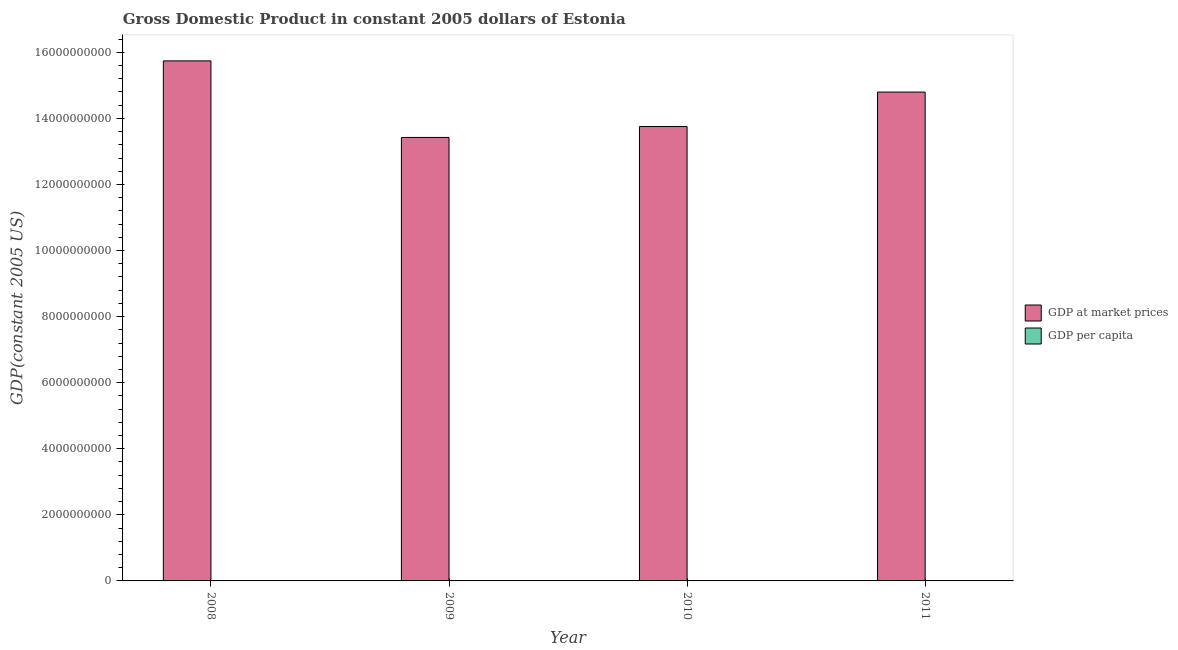How many groups of bars are there?
Provide a short and direct response. 4. What is the label of the 1st group of bars from the left?
Give a very brief answer. 2008. In how many cases, is the number of bars for a given year not equal to the number of legend labels?
Offer a very short reply. 0. What is the gdp at market prices in 2009?
Offer a very short reply. 1.34e+1. Across all years, what is the maximum gdp per capita?
Provide a short and direct response. 1.18e+04. Across all years, what is the minimum gdp at market prices?
Offer a very short reply. 1.34e+1. In which year was the gdp per capita maximum?
Make the answer very short. 2008. What is the total gdp at market prices in the graph?
Ensure brevity in your answer.  5.77e+1. What is the difference between the gdp per capita in 2008 and that in 2009?
Your answer should be compact. 1713.92. What is the difference between the gdp per capita in 2011 and the gdp at market prices in 2009?
Your response must be concise. 1088.26. What is the average gdp at market prices per year?
Ensure brevity in your answer.  1.44e+1. In the year 2010, what is the difference between the gdp at market prices and gdp per capita?
Keep it short and to the point. 0. In how many years, is the gdp per capita greater than 800000000 US$?
Offer a terse response. 0. What is the ratio of the gdp per capita in 2008 to that in 2011?
Offer a terse response. 1.06. Is the gdp at market prices in 2008 less than that in 2009?
Provide a succinct answer. No. What is the difference between the highest and the second highest gdp per capita?
Give a very brief answer. 625.66. What is the difference between the highest and the lowest gdp per capita?
Make the answer very short. 1713.92. In how many years, is the gdp at market prices greater than the average gdp at market prices taken over all years?
Your answer should be very brief. 2. What does the 2nd bar from the left in 2011 represents?
Make the answer very short. GDP per capita. What does the 1st bar from the right in 2008 represents?
Make the answer very short. GDP per capita. Are all the bars in the graph horizontal?
Your response must be concise. No. What is the difference between two consecutive major ticks on the Y-axis?
Offer a very short reply. 2.00e+09. Are the values on the major ticks of Y-axis written in scientific E-notation?
Ensure brevity in your answer.  No. Does the graph contain any zero values?
Provide a short and direct response. No. How many legend labels are there?
Provide a short and direct response. 2. What is the title of the graph?
Offer a terse response. Gross Domestic Product in constant 2005 dollars of Estonia. Does "Secondary education" appear as one of the legend labels in the graph?
Your response must be concise. No. What is the label or title of the Y-axis?
Ensure brevity in your answer.  GDP(constant 2005 US). What is the GDP(constant 2005 US) in GDP at market prices in 2008?
Make the answer very short. 1.57e+1. What is the GDP(constant 2005 US) of GDP per capita in 2008?
Your response must be concise. 1.18e+04. What is the GDP(constant 2005 US) in GDP at market prices in 2009?
Give a very brief answer. 1.34e+1. What is the GDP(constant 2005 US) of GDP per capita in 2009?
Your answer should be very brief. 1.01e+04. What is the GDP(constant 2005 US) of GDP at market prices in 2010?
Give a very brief answer. 1.38e+1. What is the GDP(constant 2005 US) of GDP per capita in 2010?
Keep it short and to the point. 1.03e+04. What is the GDP(constant 2005 US) in GDP at market prices in 2011?
Your answer should be compact. 1.48e+1. What is the GDP(constant 2005 US) in GDP per capita in 2011?
Provide a succinct answer. 1.11e+04. Across all years, what is the maximum GDP(constant 2005 US) of GDP at market prices?
Offer a very short reply. 1.57e+1. Across all years, what is the maximum GDP(constant 2005 US) in GDP per capita?
Offer a terse response. 1.18e+04. Across all years, what is the minimum GDP(constant 2005 US) of GDP at market prices?
Give a very brief answer. 1.34e+1. Across all years, what is the minimum GDP(constant 2005 US) in GDP per capita?
Your answer should be compact. 1.01e+04. What is the total GDP(constant 2005 US) in GDP at market prices in the graph?
Your response must be concise. 5.77e+1. What is the total GDP(constant 2005 US) in GDP per capita in the graph?
Keep it short and to the point. 4.33e+04. What is the difference between the GDP(constant 2005 US) in GDP at market prices in 2008 and that in 2009?
Your answer should be compact. 2.32e+09. What is the difference between the GDP(constant 2005 US) of GDP per capita in 2008 and that in 2009?
Your answer should be very brief. 1713.92. What is the difference between the GDP(constant 2005 US) in GDP at market prices in 2008 and that in 2010?
Ensure brevity in your answer.  1.99e+09. What is the difference between the GDP(constant 2005 US) in GDP per capita in 2008 and that in 2010?
Provide a succinct answer. 1442.69. What is the difference between the GDP(constant 2005 US) of GDP at market prices in 2008 and that in 2011?
Make the answer very short. 9.44e+08. What is the difference between the GDP(constant 2005 US) of GDP per capita in 2008 and that in 2011?
Provide a short and direct response. 625.66. What is the difference between the GDP(constant 2005 US) in GDP at market prices in 2009 and that in 2010?
Your response must be concise. -3.31e+08. What is the difference between the GDP(constant 2005 US) in GDP per capita in 2009 and that in 2010?
Make the answer very short. -271.23. What is the difference between the GDP(constant 2005 US) in GDP at market prices in 2009 and that in 2011?
Your answer should be compact. -1.37e+09. What is the difference between the GDP(constant 2005 US) of GDP per capita in 2009 and that in 2011?
Provide a short and direct response. -1088.26. What is the difference between the GDP(constant 2005 US) of GDP at market prices in 2010 and that in 2011?
Make the answer very short. -1.04e+09. What is the difference between the GDP(constant 2005 US) in GDP per capita in 2010 and that in 2011?
Give a very brief answer. -817.03. What is the difference between the GDP(constant 2005 US) in GDP at market prices in 2008 and the GDP(constant 2005 US) in GDP per capita in 2009?
Your answer should be compact. 1.57e+1. What is the difference between the GDP(constant 2005 US) in GDP at market prices in 2008 and the GDP(constant 2005 US) in GDP per capita in 2010?
Your answer should be compact. 1.57e+1. What is the difference between the GDP(constant 2005 US) of GDP at market prices in 2008 and the GDP(constant 2005 US) of GDP per capita in 2011?
Offer a very short reply. 1.57e+1. What is the difference between the GDP(constant 2005 US) of GDP at market prices in 2009 and the GDP(constant 2005 US) of GDP per capita in 2010?
Keep it short and to the point. 1.34e+1. What is the difference between the GDP(constant 2005 US) in GDP at market prices in 2009 and the GDP(constant 2005 US) in GDP per capita in 2011?
Keep it short and to the point. 1.34e+1. What is the difference between the GDP(constant 2005 US) of GDP at market prices in 2010 and the GDP(constant 2005 US) of GDP per capita in 2011?
Offer a very short reply. 1.38e+1. What is the average GDP(constant 2005 US) of GDP at market prices per year?
Provide a short and direct response. 1.44e+1. What is the average GDP(constant 2005 US) of GDP per capita per year?
Your answer should be very brief. 1.08e+04. In the year 2008, what is the difference between the GDP(constant 2005 US) of GDP at market prices and GDP(constant 2005 US) of GDP per capita?
Provide a short and direct response. 1.57e+1. In the year 2009, what is the difference between the GDP(constant 2005 US) of GDP at market prices and GDP(constant 2005 US) of GDP per capita?
Ensure brevity in your answer.  1.34e+1. In the year 2010, what is the difference between the GDP(constant 2005 US) of GDP at market prices and GDP(constant 2005 US) of GDP per capita?
Your answer should be very brief. 1.38e+1. In the year 2011, what is the difference between the GDP(constant 2005 US) of GDP at market prices and GDP(constant 2005 US) of GDP per capita?
Ensure brevity in your answer.  1.48e+1. What is the ratio of the GDP(constant 2005 US) of GDP at market prices in 2008 to that in 2009?
Offer a very short reply. 1.17. What is the ratio of the GDP(constant 2005 US) of GDP per capita in 2008 to that in 2009?
Keep it short and to the point. 1.17. What is the ratio of the GDP(constant 2005 US) in GDP at market prices in 2008 to that in 2010?
Provide a succinct answer. 1.14. What is the ratio of the GDP(constant 2005 US) of GDP per capita in 2008 to that in 2010?
Your answer should be compact. 1.14. What is the ratio of the GDP(constant 2005 US) of GDP at market prices in 2008 to that in 2011?
Offer a terse response. 1.06. What is the ratio of the GDP(constant 2005 US) of GDP per capita in 2008 to that in 2011?
Your response must be concise. 1.06. What is the ratio of the GDP(constant 2005 US) in GDP per capita in 2009 to that in 2010?
Ensure brevity in your answer.  0.97. What is the ratio of the GDP(constant 2005 US) in GDP at market prices in 2009 to that in 2011?
Make the answer very short. 0.91. What is the ratio of the GDP(constant 2005 US) of GDP per capita in 2009 to that in 2011?
Your answer should be compact. 0.9. What is the ratio of the GDP(constant 2005 US) in GDP at market prices in 2010 to that in 2011?
Provide a short and direct response. 0.93. What is the ratio of the GDP(constant 2005 US) of GDP per capita in 2010 to that in 2011?
Offer a very short reply. 0.93. What is the difference between the highest and the second highest GDP(constant 2005 US) of GDP at market prices?
Make the answer very short. 9.44e+08. What is the difference between the highest and the second highest GDP(constant 2005 US) of GDP per capita?
Provide a succinct answer. 625.66. What is the difference between the highest and the lowest GDP(constant 2005 US) of GDP at market prices?
Provide a succinct answer. 2.32e+09. What is the difference between the highest and the lowest GDP(constant 2005 US) of GDP per capita?
Offer a very short reply. 1713.92. 